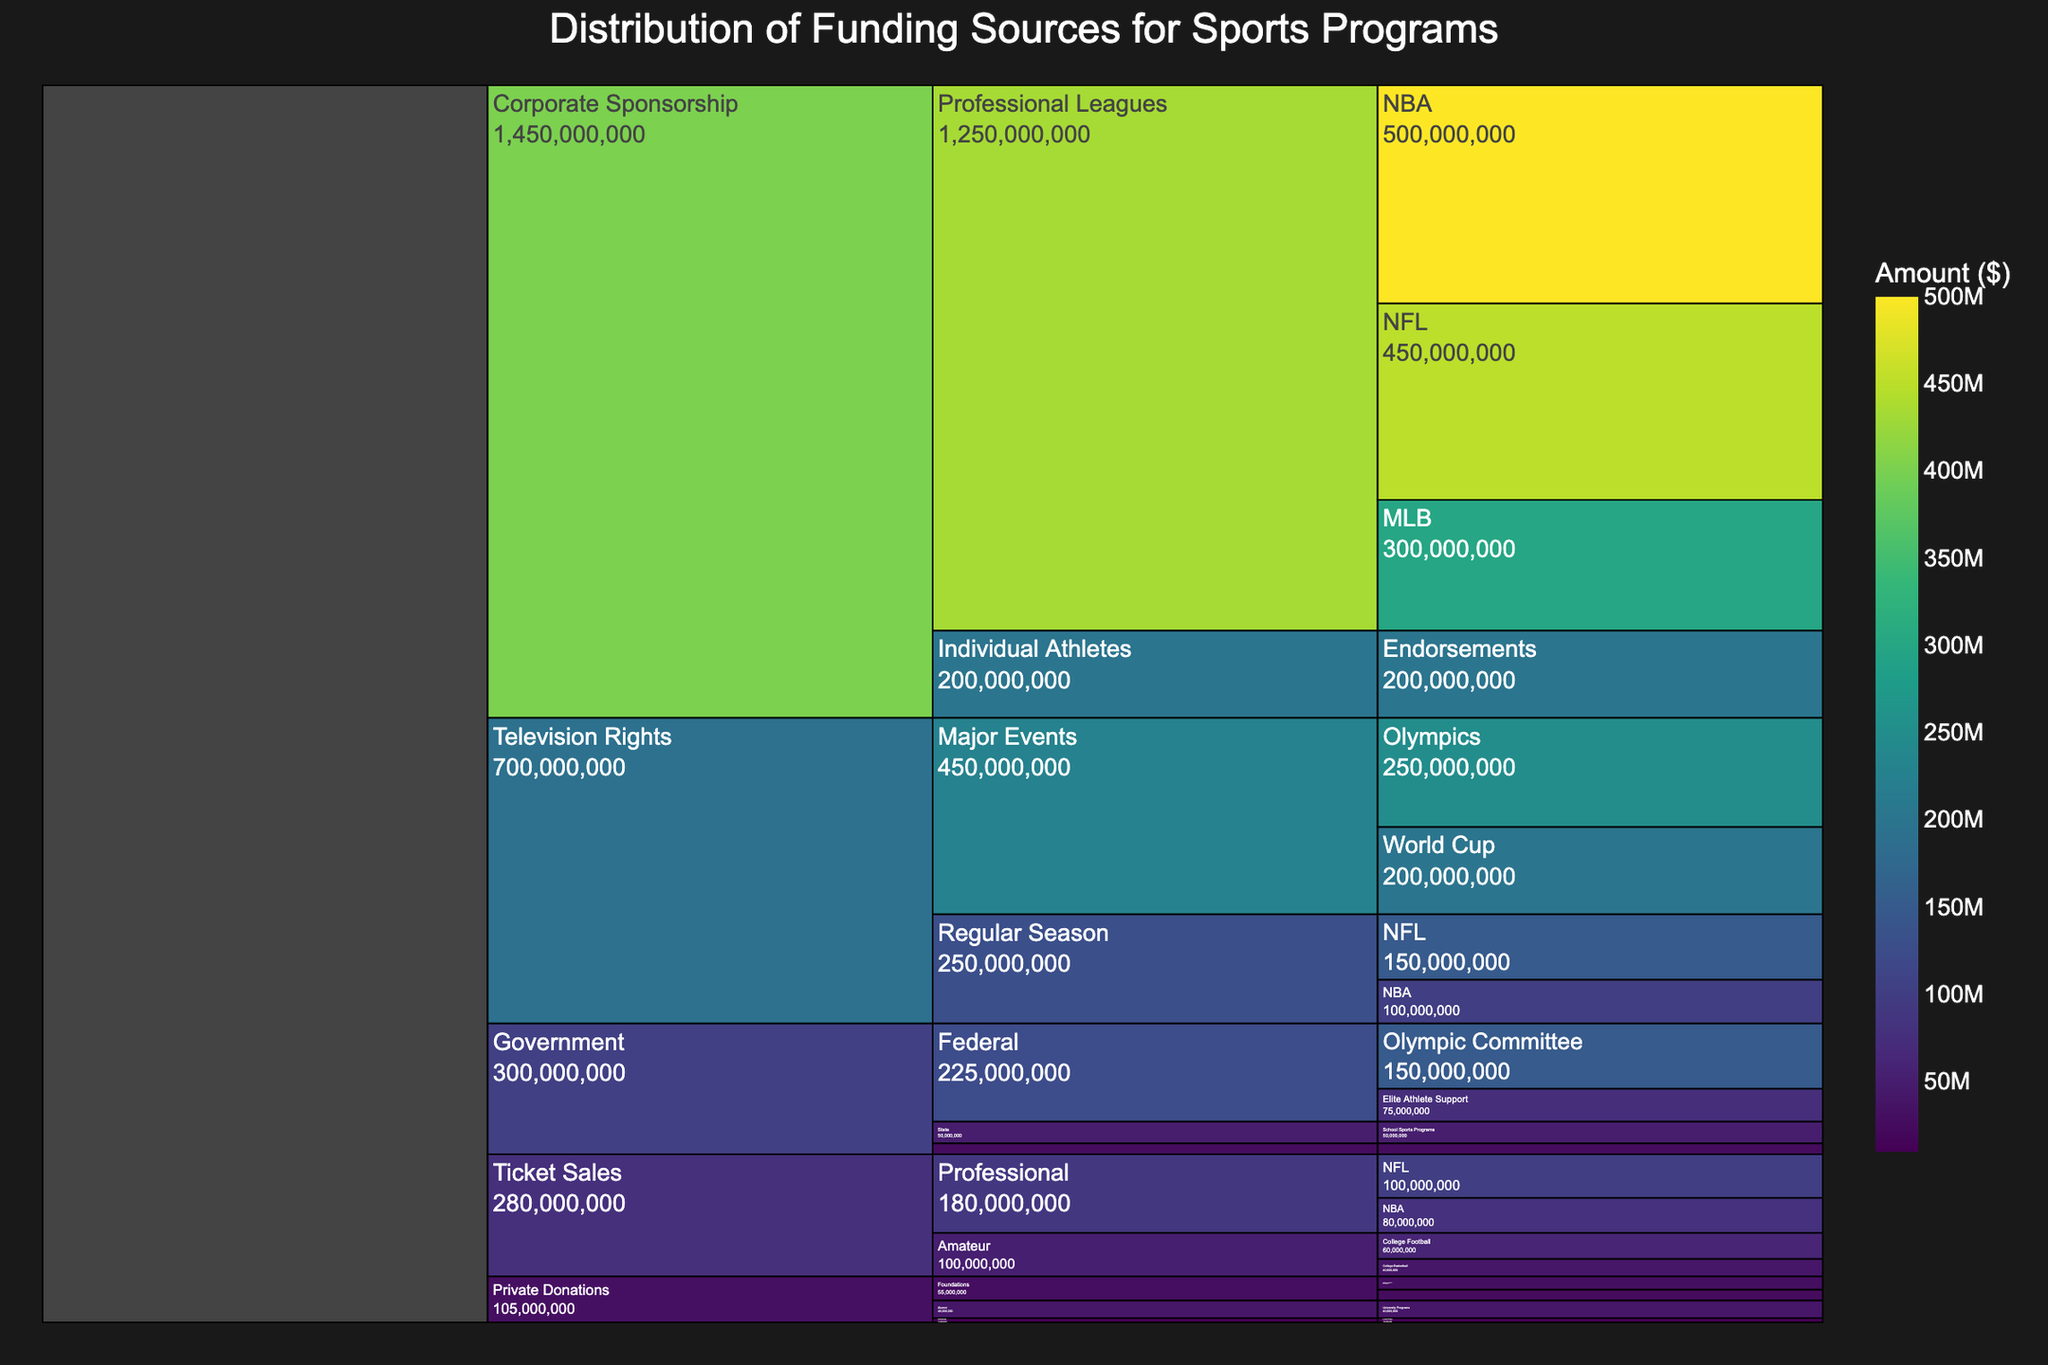What is the total amount of funding provided by the Government? To find the total amount of funding from the Government, sum up all the amounts from its subcategories: Federal (150M + 75M), State (50M), and Local (25M). So, 150M + 75M + 50M + 25M = 300M.
Answer: $300,000,000 How much funding comes from Television Rights for Major Events compared to Regular Season events? Television Rights for Major Events includes the Olympics ($250M) and World Cup ($200M) totaling $450M, while Regular Season includes NFL ($150M) and NBA ($100M) totaling $250M. Therefore, 450M - 250M = 200M more for Major Events.
Answer: $200,000,000 Which source provides the most funding overall? The source providing the most funding can be determined by looking at the amounts in each main category. Corporate Sponsorship amounts to the highest with NBA ($500M), NFL ($450M), MLB ($300M), and Individual Athletes Endorsements ($200M), totaling $1.45 billion.
Answer: Corporate Sponsorship What is the total amount of funding from Corporate Sponsorship and Private Donations combined? The total amount from Corporate Sponsorship is the sum of NBA ($500M), NFL ($450M), MLB ($300M), and Endorsements ($200M), which gives $1.45 billion. The total from Private Donations is the sum of Gates Foundation ($30M), Nike Foundation ($25M), University Programs ($40M), and Local Clubs ($10M), totaling $105M. So, $1.45 billion + $105M = $1.555 billion.
Answer: $1,555,000,000 What percentage of Government funding goes to the Olympic Committee? Government funding totals $300M, and the Olympic Committee receives $150M. The percentage is (150M / 300M) * 100% = 50%.
Answer: 50% Which individual sport league receives the highest corporate sponsorship? The highest corporate sponsorship among individual sport leagues can be identified by the largest value under Corporate Sponsorship > Professional Leagues, which is the NBA ($500M).
Answer: NBA Compare the total funding between Ticket Sales for Professional and Amateur sports. Ticket Sales for Professional includes NFL ($100M) and NBA ($80M) totaling $180M, while Amateur includes College Football ($60M) and College Basketball ($40M) totaling $100M. Therefore, $180M - $100M = $80M more for Professional sports.
Answer: $80,000,000 Which foundation provides the most private donations? To identify the foundation providing the most private donations, compare the values in the Foundations subcategory. Gates Foundation provides $30M which is the highest.
Answer: Gates Foundation 